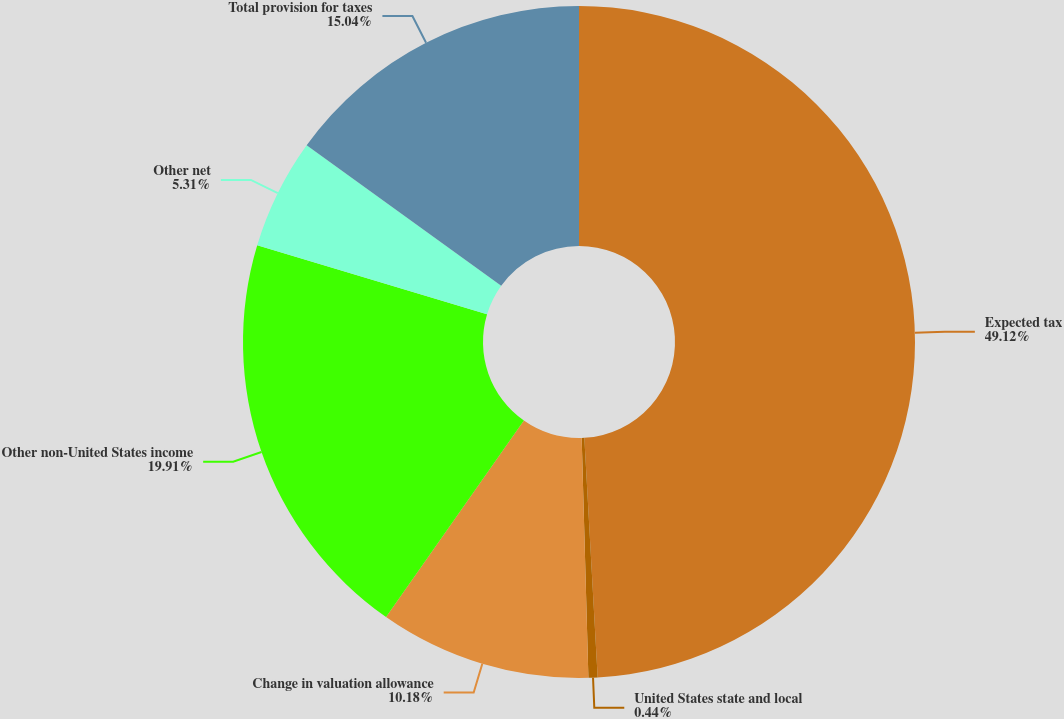Convert chart to OTSL. <chart><loc_0><loc_0><loc_500><loc_500><pie_chart><fcel>Expected tax<fcel>United States state and local<fcel>Change in valuation allowance<fcel>Other non-United States income<fcel>Other net<fcel>Total provision for taxes<nl><fcel>49.11%<fcel>0.44%<fcel>10.18%<fcel>19.91%<fcel>5.31%<fcel>15.04%<nl></chart> 